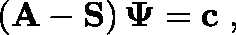<formula> <loc_0><loc_0><loc_500><loc_500>\left ( A - S \right ) \Psi = c \, ,</formula> 